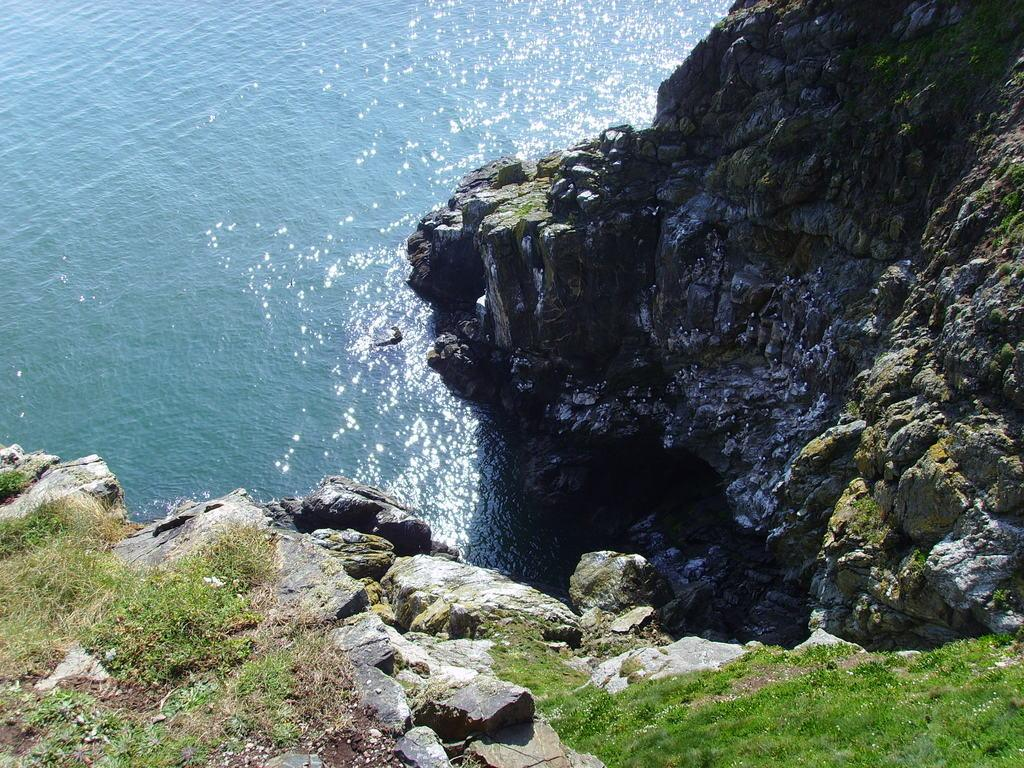What is the main feature in the center of the image? There is water, hills, and grass in the center of the image. Can you describe the landscape in the image? The landscape in the image features water, hills, and grass. What type of vegetation is present in the image? Grass is present in the image. How many corn stalks can be seen growing in the image? There are no corn stalks present in the image. What type of fruit is growing on the trees in the image? There are no trees or cherries present in the image. 